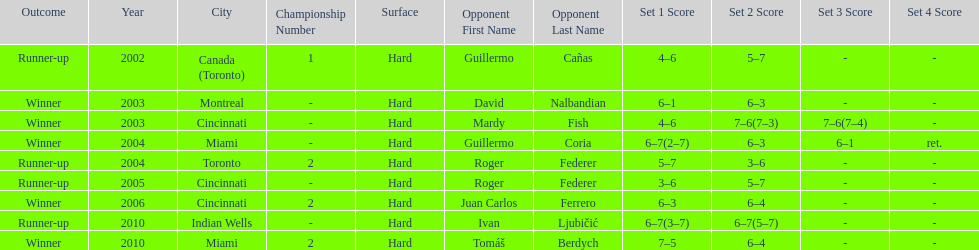How many consecutive years was there a hard surface at the championship? 9. 